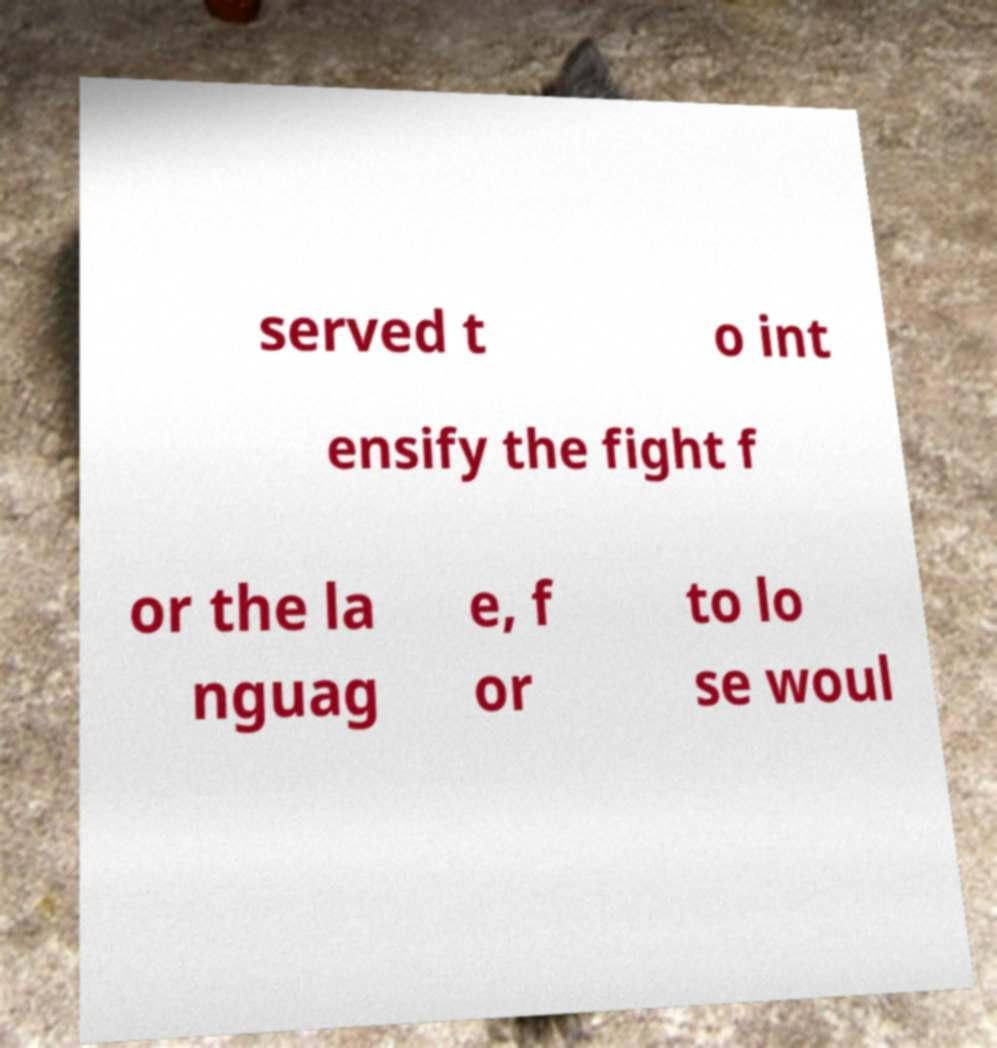Please read and relay the text visible in this image. What does it say? served t o int ensify the fight f or the la nguag e, f or to lo se woul 